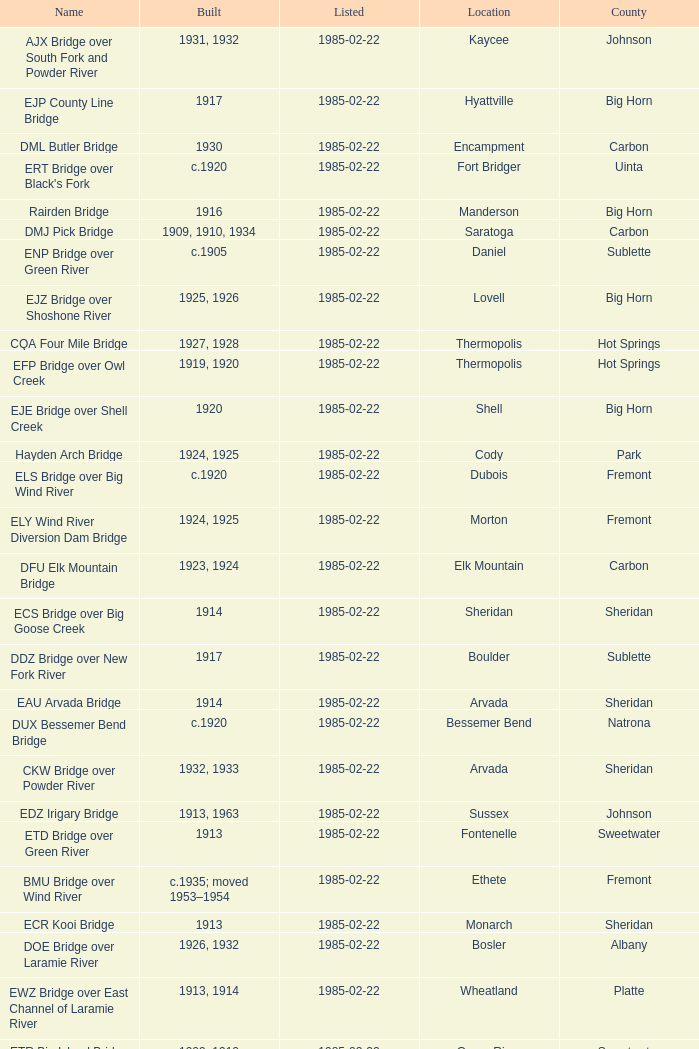What is the county of the bridge in Boulder? Sublette. 